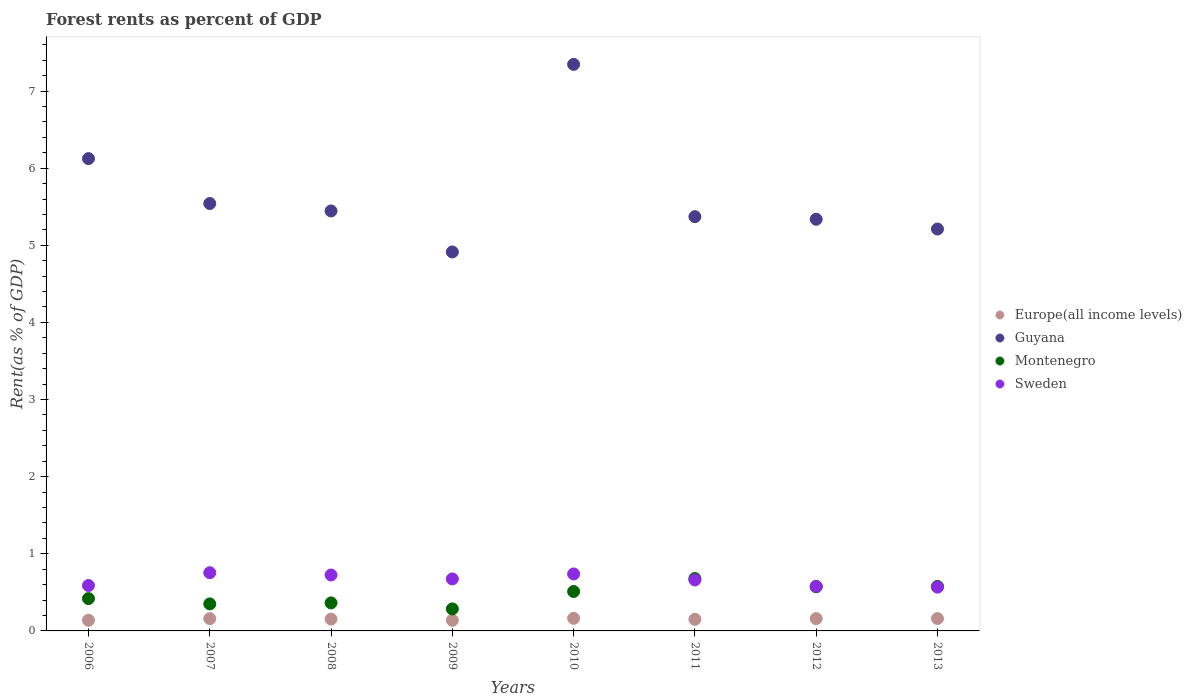What is the forest rent in Montenegro in 2011?
Offer a very short reply. 0.68. Across all years, what is the maximum forest rent in Europe(all income levels)?
Keep it short and to the point. 0.16. Across all years, what is the minimum forest rent in Sweden?
Your response must be concise. 0.57. In which year was the forest rent in Europe(all income levels) minimum?
Your answer should be very brief. 2009. What is the total forest rent in Europe(all income levels) in the graph?
Offer a very short reply. 1.22. What is the difference between the forest rent in Montenegro in 2008 and that in 2011?
Offer a terse response. -0.32. What is the difference between the forest rent in Guyana in 2013 and the forest rent in Montenegro in 2012?
Ensure brevity in your answer.  4.64. What is the average forest rent in Montenegro per year?
Provide a succinct answer. 0.47. In the year 2007, what is the difference between the forest rent in Montenegro and forest rent in Guyana?
Give a very brief answer. -5.19. What is the ratio of the forest rent in Sweden in 2006 to that in 2011?
Provide a short and direct response. 0.89. Is the forest rent in Guyana in 2007 less than that in 2009?
Give a very brief answer. No. What is the difference between the highest and the second highest forest rent in Europe(all income levels)?
Make the answer very short. 0. What is the difference between the highest and the lowest forest rent in Montenegro?
Make the answer very short. 0.39. In how many years, is the forest rent in Europe(all income levels) greater than the average forest rent in Europe(all income levels) taken over all years?
Make the answer very short. 5. Does the forest rent in Guyana monotonically increase over the years?
Your answer should be compact. No. Is the forest rent in Sweden strictly greater than the forest rent in Europe(all income levels) over the years?
Ensure brevity in your answer.  Yes. How many dotlines are there?
Offer a terse response. 4. Are the values on the major ticks of Y-axis written in scientific E-notation?
Your response must be concise. No. Does the graph contain any zero values?
Your answer should be compact. No. Does the graph contain grids?
Ensure brevity in your answer.  No. How many legend labels are there?
Your answer should be compact. 4. What is the title of the graph?
Your answer should be compact. Forest rents as percent of GDP. What is the label or title of the X-axis?
Provide a succinct answer. Years. What is the label or title of the Y-axis?
Keep it short and to the point. Rent(as % of GDP). What is the Rent(as % of GDP) of Europe(all income levels) in 2006?
Your answer should be very brief. 0.14. What is the Rent(as % of GDP) in Guyana in 2006?
Provide a succinct answer. 6.12. What is the Rent(as % of GDP) of Montenegro in 2006?
Your answer should be compact. 0.42. What is the Rent(as % of GDP) of Sweden in 2006?
Your response must be concise. 0.59. What is the Rent(as % of GDP) of Europe(all income levels) in 2007?
Your answer should be very brief. 0.16. What is the Rent(as % of GDP) of Guyana in 2007?
Keep it short and to the point. 5.54. What is the Rent(as % of GDP) in Montenegro in 2007?
Provide a succinct answer. 0.35. What is the Rent(as % of GDP) in Sweden in 2007?
Offer a very short reply. 0.75. What is the Rent(as % of GDP) of Europe(all income levels) in 2008?
Give a very brief answer. 0.15. What is the Rent(as % of GDP) in Guyana in 2008?
Offer a very short reply. 5.45. What is the Rent(as % of GDP) in Montenegro in 2008?
Make the answer very short. 0.36. What is the Rent(as % of GDP) in Sweden in 2008?
Your response must be concise. 0.73. What is the Rent(as % of GDP) of Europe(all income levels) in 2009?
Offer a very short reply. 0.14. What is the Rent(as % of GDP) of Guyana in 2009?
Your answer should be compact. 4.91. What is the Rent(as % of GDP) of Montenegro in 2009?
Offer a very short reply. 0.29. What is the Rent(as % of GDP) in Sweden in 2009?
Offer a terse response. 0.67. What is the Rent(as % of GDP) in Europe(all income levels) in 2010?
Give a very brief answer. 0.16. What is the Rent(as % of GDP) in Guyana in 2010?
Ensure brevity in your answer.  7.35. What is the Rent(as % of GDP) of Montenegro in 2010?
Keep it short and to the point. 0.51. What is the Rent(as % of GDP) in Sweden in 2010?
Keep it short and to the point. 0.74. What is the Rent(as % of GDP) of Europe(all income levels) in 2011?
Ensure brevity in your answer.  0.15. What is the Rent(as % of GDP) in Guyana in 2011?
Provide a short and direct response. 5.37. What is the Rent(as % of GDP) in Montenegro in 2011?
Give a very brief answer. 0.68. What is the Rent(as % of GDP) of Sweden in 2011?
Give a very brief answer. 0.66. What is the Rent(as % of GDP) of Europe(all income levels) in 2012?
Offer a terse response. 0.16. What is the Rent(as % of GDP) of Guyana in 2012?
Offer a very short reply. 5.34. What is the Rent(as % of GDP) of Montenegro in 2012?
Offer a terse response. 0.57. What is the Rent(as % of GDP) of Sweden in 2012?
Provide a succinct answer. 0.58. What is the Rent(as % of GDP) in Europe(all income levels) in 2013?
Ensure brevity in your answer.  0.16. What is the Rent(as % of GDP) of Guyana in 2013?
Provide a succinct answer. 5.21. What is the Rent(as % of GDP) in Montenegro in 2013?
Provide a succinct answer. 0.58. What is the Rent(as % of GDP) in Sweden in 2013?
Offer a very short reply. 0.57. Across all years, what is the maximum Rent(as % of GDP) in Europe(all income levels)?
Your answer should be compact. 0.16. Across all years, what is the maximum Rent(as % of GDP) of Guyana?
Provide a short and direct response. 7.35. Across all years, what is the maximum Rent(as % of GDP) of Montenegro?
Keep it short and to the point. 0.68. Across all years, what is the maximum Rent(as % of GDP) in Sweden?
Your answer should be very brief. 0.75. Across all years, what is the minimum Rent(as % of GDP) of Europe(all income levels)?
Give a very brief answer. 0.14. Across all years, what is the minimum Rent(as % of GDP) in Guyana?
Offer a very short reply. 4.91. Across all years, what is the minimum Rent(as % of GDP) in Montenegro?
Ensure brevity in your answer.  0.29. Across all years, what is the minimum Rent(as % of GDP) of Sweden?
Your response must be concise. 0.57. What is the total Rent(as % of GDP) in Europe(all income levels) in the graph?
Provide a succinct answer. 1.22. What is the total Rent(as % of GDP) in Guyana in the graph?
Make the answer very short. 45.29. What is the total Rent(as % of GDP) in Montenegro in the graph?
Keep it short and to the point. 3.76. What is the total Rent(as % of GDP) of Sweden in the graph?
Your answer should be very brief. 5.29. What is the difference between the Rent(as % of GDP) of Europe(all income levels) in 2006 and that in 2007?
Your answer should be compact. -0.02. What is the difference between the Rent(as % of GDP) in Guyana in 2006 and that in 2007?
Offer a terse response. 0.58. What is the difference between the Rent(as % of GDP) in Montenegro in 2006 and that in 2007?
Provide a succinct answer. 0.07. What is the difference between the Rent(as % of GDP) of Sweden in 2006 and that in 2007?
Your answer should be very brief. -0.17. What is the difference between the Rent(as % of GDP) of Europe(all income levels) in 2006 and that in 2008?
Provide a short and direct response. -0.02. What is the difference between the Rent(as % of GDP) in Guyana in 2006 and that in 2008?
Keep it short and to the point. 0.68. What is the difference between the Rent(as % of GDP) of Montenegro in 2006 and that in 2008?
Your answer should be compact. 0.06. What is the difference between the Rent(as % of GDP) of Sweden in 2006 and that in 2008?
Make the answer very short. -0.14. What is the difference between the Rent(as % of GDP) of Europe(all income levels) in 2006 and that in 2009?
Ensure brevity in your answer.  0. What is the difference between the Rent(as % of GDP) in Guyana in 2006 and that in 2009?
Provide a short and direct response. 1.21. What is the difference between the Rent(as % of GDP) in Montenegro in 2006 and that in 2009?
Provide a succinct answer. 0.13. What is the difference between the Rent(as % of GDP) of Sweden in 2006 and that in 2009?
Provide a succinct answer. -0.09. What is the difference between the Rent(as % of GDP) in Europe(all income levels) in 2006 and that in 2010?
Your answer should be very brief. -0.03. What is the difference between the Rent(as % of GDP) of Guyana in 2006 and that in 2010?
Your answer should be compact. -1.22. What is the difference between the Rent(as % of GDP) of Montenegro in 2006 and that in 2010?
Make the answer very short. -0.09. What is the difference between the Rent(as % of GDP) of Sweden in 2006 and that in 2010?
Your answer should be compact. -0.15. What is the difference between the Rent(as % of GDP) of Europe(all income levels) in 2006 and that in 2011?
Keep it short and to the point. -0.01. What is the difference between the Rent(as % of GDP) of Guyana in 2006 and that in 2011?
Your response must be concise. 0.75. What is the difference between the Rent(as % of GDP) in Montenegro in 2006 and that in 2011?
Give a very brief answer. -0.26. What is the difference between the Rent(as % of GDP) in Sweden in 2006 and that in 2011?
Give a very brief answer. -0.07. What is the difference between the Rent(as % of GDP) in Europe(all income levels) in 2006 and that in 2012?
Your response must be concise. -0.02. What is the difference between the Rent(as % of GDP) in Guyana in 2006 and that in 2012?
Your answer should be compact. 0.79. What is the difference between the Rent(as % of GDP) in Montenegro in 2006 and that in 2012?
Keep it short and to the point. -0.15. What is the difference between the Rent(as % of GDP) of Sweden in 2006 and that in 2012?
Ensure brevity in your answer.  0.01. What is the difference between the Rent(as % of GDP) of Europe(all income levels) in 2006 and that in 2013?
Provide a short and direct response. -0.02. What is the difference between the Rent(as % of GDP) of Montenegro in 2006 and that in 2013?
Provide a succinct answer. -0.16. What is the difference between the Rent(as % of GDP) of Sweden in 2006 and that in 2013?
Provide a short and direct response. 0.02. What is the difference between the Rent(as % of GDP) in Europe(all income levels) in 2007 and that in 2008?
Your answer should be compact. 0.01. What is the difference between the Rent(as % of GDP) in Guyana in 2007 and that in 2008?
Your answer should be very brief. 0.1. What is the difference between the Rent(as % of GDP) in Montenegro in 2007 and that in 2008?
Offer a terse response. -0.01. What is the difference between the Rent(as % of GDP) in Sweden in 2007 and that in 2008?
Your answer should be compact. 0.03. What is the difference between the Rent(as % of GDP) of Europe(all income levels) in 2007 and that in 2009?
Your answer should be compact. 0.02. What is the difference between the Rent(as % of GDP) in Guyana in 2007 and that in 2009?
Give a very brief answer. 0.63. What is the difference between the Rent(as % of GDP) in Montenegro in 2007 and that in 2009?
Provide a succinct answer. 0.06. What is the difference between the Rent(as % of GDP) in Sweden in 2007 and that in 2009?
Provide a short and direct response. 0.08. What is the difference between the Rent(as % of GDP) of Europe(all income levels) in 2007 and that in 2010?
Make the answer very short. -0. What is the difference between the Rent(as % of GDP) of Guyana in 2007 and that in 2010?
Your response must be concise. -1.8. What is the difference between the Rent(as % of GDP) of Montenegro in 2007 and that in 2010?
Give a very brief answer. -0.16. What is the difference between the Rent(as % of GDP) in Sweden in 2007 and that in 2010?
Your response must be concise. 0.02. What is the difference between the Rent(as % of GDP) in Europe(all income levels) in 2007 and that in 2011?
Make the answer very short. 0.01. What is the difference between the Rent(as % of GDP) in Guyana in 2007 and that in 2011?
Keep it short and to the point. 0.17. What is the difference between the Rent(as % of GDP) of Montenegro in 2007 and that in 2011?
Your answer should be very brief. -0.33. What is the difference between the Rent(as % of GDP) in Sweden in 2007 and that in 2011?
Give a very brief answer. 0.09. What is the difference between the Rent(as % of GDP) of Europe(all income levels) in 2007 and that in 2012?
Your answer should be compact. -0. What is the difference between the Rent(as % of GDP) of Guyana in 2007 and that in 2012?
Provide a succinct answer. 0.2. What is the difference between the Rent(as % of GDP) in Montenegro in 2007 and that in 2012?
Provide a short and direct response. -0.22. What is the difference between the Rent(as % of GDP) of Sweden in 2007 and that in 2012?
Provide a succinct answer. 0.18. What is the difference between the Rent(as % of GDP) in Europe(all income levels) in 2007 and that in 2013?
Offer a terse response. -0. What is the difference between the Rent(as % of GDP) of Guyana in 2007 and that in 2013?
Your answer should be compact. 0.33. What is the difference between the Rent(as % of GDP) of Montenegro in 2007 and that in 2013?
Give a very brief answer. -0.23. What is the difference between the Rent(as % of GDP) in Sweden in 2007 and that in 2013?
Give a very brief answer. 0.19. What is the difference between the Rent(as % of GDP) in Europe(all income levels) in 2008 and that in 2009?
Ensure brevity in your answer.  0.02. What is the difference between the Rent(as % of GDP) in Guyana in 2008 and that in 2009?
Offer a very short reply. 0.53. What is the difference between the Rent(as % of GDP) of Montenegro in 2008 and that in 2009?
Ensure brevity in your answer.  0.08. What is the difference between the Rent(as % of GDP) of Sweden in 2008 and that in 2009?
Offer a terse response. 0.05. What is the difference between the Rent(as % of GDP) of Europe(all income levels) in 2008 and that in 2010?
Your answer should be very brief. -0.01. What is the difference between the Rent(as % of GDP) in Guyana in 2008 and that in 2010?
Make the answer very short. -1.9. What is the difference between the Rent(as % of GDP) in Montenegro in 2008 and that in 2010?
Provide a succinct answer. -0.15. What is the difference between the Rent(as % of GDP) of Sweden in 2008 and that in 2010?
Provide a short and direct response. -0.01. What is the difference between the Rent(as % of GDP) of Europe(all income levels) in 2008 and that in 2011?
Offer a terse response. 0. What is the difference between the Rent(as % of GDP) of Guyana in 2008 and that in 2011?
Provide a succinct answer. 0.07. What is the difference between the Rent(as % of GDP) in Montenegro in 2008 and that in 2011?
Your answer should be compact. -0.32. What is the difference between the Rent(as % of GDP) in Sweden in 2008 and that in 2011?
Give a very brief answer. 0.06. What is the difference between the Rent(as % of GDP) in Europe(all income levels) in 2008 and that in 2012?
Provide a short and direct response. -0.01. What is the difference between the Rent(as % of GDP) in Guyana in 2008 and that in 2012?
Give a very brief answer. 0.11. What is the difference between the Rent(as % of GDP) in Montenegro in 2008 and that in 2012?
Ensure brevity in your answer.  -0.21. What is the difference between the Rent(as % of GDP) of Sweden in 2008 and that in 2012?
Offer a terse response. 0.15. What is the difference between the Rent(as % of GDP) of Europe(all income levels) in 2008 and that in 2013?
Provide a succinct answer. -0.01. What is the difference between the Rent(as % of GDP) of Guyana in 2008 and that in 2013?
Make the answer very short. 0.23. What is the difference between the Rent(as % of GDP) in Montenegro in 2008 and that in 2013?
Offer a terse response. -0.21. What is the difference between the Rent(as % of GDP) in Sweden in 2008 and that in 2013?
Your answer should be very brief. 0.16. What is the difference between the Rent(as % of GDP) of Europe(all income levels) in 2009 and that in 2010?
Offer a very short reply. -0.03. What is the difference between the Rent(as % of GDP) in Guyana in 2009 and that in 2010?
Make the answer very short. -2.43. What is the difference between the Rent(as % of GDP) in Montenegro in 2009 and that in 2010?
Your answer should be very brief. -0.23. What is the difference between the Rent(as % of GDP) of Sweden in 2009 and that in 2010?
Your answer should be very brief. -0.06. What is the difference between the Rent(as % of GDP) in Europe(all income levels) in 2009 and that in 2011?
Keep it short and to the point. -0.01. What is the difference between the Rent(as % of GDP) in Guyana in 2009 and that in 2011?
Your response must be concise. -0.46. What is the difference between the Rent(as % of GDP) in Montenegro in 2009 and that in 2011?
Provide a succinct answer. -0.39. What is the difference between the Rent(as % of GDP) of Sweden in 2009 and that in 2011?
Your answer should be compact. 0.01. What is the difference between the Rent(as % of GDP) of Europe(all income levels) in 2009 and that in 2012?
Your response must be concise. -0.02. What is the difference between the Rent(as % of GDP) in Guyana in 2009 and that in 2012?
Offer a terse response. -0.42. What is the difference between the Rent(as % of GDP) in Montenegro in 2009 and that in 2012?
Your answer should be compact. -0.29. What is the difference between the Rent(as % of GDP) of Sweden in 2009 and that in 2012?
Your answer should be compact. 0.1. What is the difference between the Rent(as % of GDP) in Europe(all income levels) in 2009 and that in 2013?
Ensure brevity in your answer.  -0.02. What is the difference between the Rent(as % of GDP) of Guyana in 2009 and that in 2013?
Make the answer very short. -0.3. What is the difference between the Rent(as % of GDP) in Montenegro in 2009 and that in 2013?
Offer a very short reply. -0.29. What is the difference between the Rent(as % of GDP) of Sweden in 2009 and that in 2013?
Your response must be concise. 0.11. What is the difference between the Rent(as % of GDP) of Europe(all income levels) in 2010 and that in 2011?
Give a very brief answer. 0.01. What is the difference between the Rent(as % of GDP) in Guyana in 2010 and that in 2011?
Offer a very short reply. 1.97. What is the difference between the Rent(as % of GDP) in Montenegro in 2010 and that in 2011?
Make the answer very short. -0.17. What is the difference between the Rent(as % of GDP) of Sweden in 2010 and that in 2011?
Your answer should be very brief. 0.08. What is the difference between the Rent(as % of GDP) of Europe(all income levels) in 2010 and that in 2012?
Provide a short and direct response. 0. What is the difference between the Rent(as % of GDP) in Guyana in 2010 and that in 2012?
Your response must be concise. 2.01. What is the difference between the Rent(as % of GDP) in Montenegro in 2010 and that in 2012?
Offer a very short reply. -0.06. What is the difference between the Rent(as % of GDP) in Sweden in 2010 and that in 2012?
Make the answer very short. 0.16. What is the difference between the Rent(as % of GDP) in Europe(all income levels) in 2010 and that in 2013?
Provide a short and direct response. 0. What is the difference between the Rent(as % of GDP) of Guyana in 2010 and that in 2013?
Your answer should be very brief. 2.13. What is the difference between the Rent(as % of GDP) of Montenegro in 2010 and that in 2013?
Give a very brief answer. -0.07. What is the difference between the Rent(as % of GDP) of Sweden in 2010 and that in 2013?
Ensure brevity in your answer.  0.17. What is the difference between the Rent(as % of GDP) of Europe(all income levels) in 2011 and that in 2012?
Ensure brevity in your answer.  -0.01. What is the difference between the Rent(as % of GDP) of Guyana in 2011 and that in 2012?
Give a very brief answer. 0.03. What is the difference between the Rent(as % of GDP) in Montenegro in 2011 and that in 2012?
Make the answer very short. 0.11. What is the difference between the Rent(as % of GDP) in Sweden in 2011 and that in 2012?
Offer a very short reply. 0.08. What is the difference between the Rent(as % of GDP) in Europe(all income levels) in 2011 and that in 2013?
Ensure brevity in your answer.  -0.01. What is the difference between the Rent(as % of GDP) in Guyana in 2011 and that in 2013?
Your response must be concise. 0.16. What is the difference between the Rent(as % of GDP) of Montenegro in 2011 and that in 2013?
Provide a short and direct response. 0.1. What is the difference between the Rent(as % of GDP) in Sweden in 2011 and that in 2013?
Ensure brevity in your answer.  0.09. What is the difference between the Rent(as % of GDP) in Europe(all income levels) in 2012 and that in 2013?
Your response must be concise. -0. What is the difference between the Rent(as % of GDP) of Guyana in 2012 and that in 2013?
Offer a very short reply. 0.13. What is the difference between the Rent(as % of GDP) in Montenegro in 2012 and that in 2013?
Make the answer very short. -0.01. What is the difference between the Rent(as % of GDP) of Sweden in 2012 and that in 2013?
Give a very brief answer. 0.01. What is the difference between the Rent(as % of GDP) in Europe(all income levels) in 2006 and the Rent(as % of GDP) in Guyana in 2007?
Your answer should be very brief. -5.4. What is the difference between the Rent(as % of GDP) of Europe(all income levels) in 2006 and the Rent(as % of GDP) of Montenegro in 2007?
Make the answer very short. -0.21. What is the difference between the Rent(as % of GDP) in Europe(all income levels) in 2006 and the Rent(as % of GDP) in Sweden in 2007?
Ensure brevity in your answer.  -0.62. What is the difference between the Rent(as % of GDP) of Guyana in 2006 and the Rent(as % of GDP) of Montenegro in 2007?
Give a very brief answer. 5.77. What is the difference between the Rent(as % of GDP) in Guyana in 2006 and the Rent(as % of GDP) in Sweden in 2007?
Your response must be concise. 5.37. What is the difference between the Rent(as % of GDP) of Montenegro in 2006 and the Rent(as % of GDP) of Sweden in 2007?
Your answer should be compact. -0.34. What is the difference between the Rent(as % of GDP) in Europe(all income levels) in 2006 and the Rent(as % of GDP) in Guyana in 2008?
Make the answer very short. -5.31. What is the difference between the Rent(as % of GDP) of Europe(all income levels) in 2006 and the Rent(as % of GDP) of Montenegro in 2008?
Your answer should be compact. -0.23. What is the difference between the Rent(as % of GDP) of Europe(all income levels) in 2006 and the Rent(as % of GDP) of Sweden in 2008?
Offer a terse response. -0.59. What is the difference between the Rent(as % of GDP) in Guyana in 2006 and the Rent(as % of GDP) in Montenegro in 2008?
Give a very brief answer. 5.76. What is the difference between the Rent(as % of GDP) in Guyana in 2006 and the Rent(as % of GDP) in Sweden in 2008?
Make the answer very short. 5.4. What is the difference between the Rent(as % of GDP) of Montenegro in 2006 and the Rent(as % of GDP) of Sweden in 2008?
Offer a terse response. -0.31. What is the difference between the Rent(as % of GDP) of Europe(all income levels) in 2006 and the Rent(as % of GDP) of Guyana in 2009?
Offer a terse response. -4.78. What is the difference between the Rent(as % of GDP) in Europe(all income levels) in 2006 and the Rent(as % of GDP) in Montenegro in 2009?
Provide a short and direct response. -0.15. What is the difference between the Rent(as % of GDP) of Europe(all income levels) in 2006 and the Rent(as % of GDP) of Sweden in 2009?
Offer a terse response. -0.54. What is the difference between the Rent(as % of GDP) of Guyana in 2006 and the Rent(as % of GDP) of Montenegro in 2009?
Provide a short and direct response. 5.84. What is the difference between the Rent(as % of GDP) in Guyana in 2006 and the Rent(as % of GDP) in Sweden in 2009?
Offer a terse response. 5.45. What is the difference between the Rent(as % of GDP) in Montenegro in 2006 and the Rent(as % of GDP) in Sweden in 2009?
Offer a terse response. -0.26. What is the difference between the Rent(as % of GDP) of Europe(all income levels) in 2006 and the Rent(as % of GDP) of Guyana in 2010?
Provide a short and direct response. -7.21. What is the difference between the Rent(as % of GDP) of Europe(all income levels) in 2006 and the Rent(as % of GDP) of Montenegro in 2010?
Offer a terse response. -0.37. What is the difference between the Rent(as % of GDP) of Europe(all income levels) in 2006 and the Rent(as % of GDP) of Sweden in 2010?
Ensure brevity in your answer.  -0.6. What is the difference between the Rent(as % of GDP) of Guyana in 2006 and the Rent(as % of GDP) of Montenegro in 2010?
Give a very brief answer. 5.61. What is the difference between the Rent(as % of GDP) of Guyana in 2006 and the Rent(as % of GDP) of Sweden in 2010?
Provide a succinct answer. 5.38. What is the difference between the Rent(as % of GDP) of Montenegro in 2006 and the Rent(as % of GDP) of Sweden in 2010?
Your answer should be compact. -0.32. What is the difference between the Rent(as % of GDP) in Europe(all income levels) in 2006 and the Rent(as % of GDP) in Guyana in 2011?
Offer a very short reply. -5.23. What is the difference between the Rent(as % of GDP) of Europe(all income levels) in 2006 and the Rent(as % of GDP) of Montenegro in 2011?
Offer a very short reply. -0.54. What is the difference between the Rent(as % of GDP) of Europe(all income levels) in 2006 and the Rent(as % of GDP) of Sweden in 2011?
Keep it short and to the point. -0.52. What is the difference between the Rent(as % of GDP) in Guyana in 2006 and the Rent(as % of GDP) in Montenegro in 2011?
Make the answer very short. 5.44. What is the difference between the Rent(as % of GDP) of Guyana in 2006 and the Rent(as % of GDP) of Sweden in 2011?
Offer a very short reply. 5.46. What is the difference between the Rent(as % of GDP) in Montenegro in 2006 and the Rent(as % of GDP) in Sweden in 2011?
Your response must be concise. -0.24. What is the difference between the Rent(as % of GDP) in Europe(all income levels) in 2006 and the Rent(as % of GDP) in Guyana in 2012?
Make the answer very short. -5.2. What is the difference between the Rent(as % of GDP) of Europe(all income levels) in 2006 and the Rent(as % of GDP) of Montenegro in 2012?
Provide a succinct answer. -0.43. What is the difference between the Rent(as % of GDP) in Europe(all income levels) in 2006 and the Rent(as % of GDP) in Sweden in 2012?
Keep it short and to the point. -0.44. What is the difference between the Rent(as % of GDP) of Guyana in 2006 and the Rent(as % of GDP) of Montenegro in 2012?
Give a very brief answer. 5.55. What is the difference between the Rent(as % of GDP) of Guyana in 2006 and the Rent(as % of GDP) of Sweden in 2012?
Your response must be concise. 5.55. What is the difference between the Rent(as % of GDP) in Montenegro in 2006 and the Rent(as % of GDP) in Sweden in 2012?
Ensure brevity in your answer.  -0.16. What is the difference between the Rent(as % of GDP) of Europe(all income levels) in 2006 and the Rent(as % of GDP) of Guyana in 2013?
Offer a terse response. -5.07. What is the difference between the Rent(as % of GDP) of Europe(all income levels) in 2006 and the Rent(as % of GDP) of Montenegro in 2013?
Offer a terse response. -0.44. What is the difference between the Rent(as % of GDP) of Europe(all income levels) in 2006 and the Rent(as % of GDP) of Sweden in 2013?
Offer a very short reply. -0.43. What is the difference between the Rent(as % of GDP) in Guyana in 2006 and the Rent(as % of GDP) in Montenegro in 2013?
Your response must be concise. 5.55. What is the difference between the Rent(as % of GDP) in Guyana in 2006 and the Rent(as % of GDP) in Sweden in 2013?
Keep it short and to the point. 5.56. What is the difference between the Rent(as % of GDP) of Montenegro in 2006 and the Rent(as % of GDP) of Sweden in 2013?
Ensure brevity in your answer.  -0.15. What is the difference between the Rent(as % of GDP) of Europe(all income levels) in 2007 and the Rent(as % of GDP) of Guyana in 2008?
Make the answer very short. -5.29. What is the difference between the Rent(as % of GDP) of Europe(all income levels) in 2007 and the Rent(as % of GDP) of Montenegro in 2008?
Your response must be concise. -0.2. What is the difference between the Rent(as % of GDP) in Europe(all income levels) in 2007 and the Rent(as % of GDP) in Sweden in 2008?
Offer a terse response. -0.57. What is the difference between the Rent(as % of GDP) of Guyana in 2007 and the Rent(as % of GDP) of Montenegro in 2008?
Provide a succinct answer. 5.18. What is the difference between the Rent(as % of GDP) in Guyana in 2007 and the Rent(as % of GDP) in Sweden in 2008?
Give a very brief answer. 4.82. What is the difference between the Rent(as % of GDP) in Montenegro in 2007 and the Rent(as % of GDP) in Sweden in 2008?
Ensure brevity in your answer.  -0.37. What is the difference between the Rent(as % of GDP) in Europe(all income levels) in 2007 and the Rent(as % of GDP) in Guyana in 2009?
Your response must be concise. -4.75. What is the difference between the Rent(as % of GDP) in Europe(all income levels) in 2007 and the Rent(as % of GDP) in Montenegro in 2009?
Ensure brevity in your answer.  -0.13. What is the difference between the Rent(as % of GDP) of Europe(all income levels) in 2007 and the Rent(as % of GDP) of Sweden in 2009?
Ensure brevity in your answer.  -0.52. What is the difference between the Rent(as % of GDP) in Guyana in 2007 and the Rent(as % of GDP) in Montenegro in 2009?
Your answer should be very brief. 5.26. What is the difference between the Rent(as % of GDP) in Guyana in 2007 and the Rent(as % of GDP) in Sweden in 2009?
Offer a very short reply. 4.87. What is the difference between the Rent(as % of GDP) in Montenegro in 2007 and the Rent(as % of GDP) in Sweden in 2009?
Offer a very short reply. -0.32. What is the difference between the Rent(as % of GDP) in Europe(all income levels) in 2007 and the Rent(as % of GDP) in Guyana in 2010?
Your response must be concise. -7.19. What is the difference between the Rent(as % of GDP) of Europe(all income levels) in 2007 and the Rent(as % of GDP) of Montenegro in 2010?
Offer a very short reply. -0.35. What is the difference between the Rent(as % of GDP) of Europe(all income levels) in 2007 and the Rent(as % of GDP) of Sweden in 2010?
Your answer should be compact. -0.58. What is the difference between the Rent(as % of GDP) of Guyana in 2007 and the Rent(as % of GDP) of Montenegro in 2010?
Ensure brevity in your answer.  5.03. What is the difference between the Rent(as % of GDP) in Guyana in 2007 and the Rent(as % of GDP) in Sweden in 2010?
Your answer should be very brief. 4.8. What is the difference between the Rent(as % of GDP) of Montenegro in 2007 and the Rent(as % of GDP) of Sweden in 2010?
Give a very brief answer. -0.39. What is the difference between the Rent(as % of GDP) in Europe(all income levels) in 2007 and the Rent(as % of GDP) in Guyana in 2011?
Provide a succinct answer. -5.21. What is the difference between the Rent(as % of GDP) of Europe(all income levels) in 2007 and the Rent(as % of GDP) of Montenegro in 2011?
Your answer should be compact. -0.52. What is the difference between the Rent(as % of GDP) in Europe(all income levels) in 2007 and the Rent(as % of GDP) in Sweden in 2011?
Make the answer very short. -0.5. What is the difference between the Rent(as % of GDP) of Guyana in 2007 and the Rent(as % of GDP) of Montenegro in 2011?
Give a very brief answer. 4.86. What is the difference between the Rent(as % of GDP) of Guyana in 2007 and the Rent(as % of GDP) of Sweden in 2011?
Your answer should be very brief. 4.88. What is the difference between the Rent(as % of GDP) of Montenegro in 2007 and the Rent(as % of GDP) of Sweden in 2011?
Give a very brief answer. -0.31. What is the difference between the Rent(as % of GDP) of Europe(all income levels) in 2007 and the Rent(as % of GDP) of Guyana in 2012?
Give a very brief answer. -5.18. What is the difference between the Rent(as % of GDP) of Europe(all income levels) in 2007 and the Rent(as % of GDP) of Montenegro in 2012?
Provide a succinct answer. -0.41. What is the difference between the Rent(as % of GDP) in Europe(all income levels) in 2007 and the Rent(as % of GDP) in Sweden in 2012?
Offer a terse response. -0.42. What is the difference between the Rent(as % of GDP) in Guyana in 2007 and the Rent(as % of GDP) in Montenegro in 2012?
Provide a succinct answer. 4.97. What is the difference between the Rent(as % of GDP) in Guyana in 2007 and the Rent(as % of GDP) in Sweden in 2012?
Offer a terse response. 4.96. What is the difference between the Rent(as % of GDP) of Montenegro in 2007 and the Rent(as % of GDP) of Sweden in 2012?
Give a very brief answer. -0.23. What is the difference between the Rent(as % of GDP) of Europe(all income levels) in 2007 and the Rent(as % of GDP) of Guyana in 2013?
Offer a terse response. -5.05. What is the difference between the Rent(as % of GDP) in Europe(all income levels) in 2007 and the Rent(as % of GDP) in Montenegro in 2013?
Give a very brief answer. -0.42. What is the difference between the Rent(as % of GDP) of Europe(all income levels) in 2007 and the Rent(as % of GDP) of Sweden in 2013?
Your response must be concise. -0.41. What is the difference between the Rent(as % of GDP) in Guyana in 2007 and the Rent(as % of GDP) in Montenegro in 2013?
Offer a very short reply. 4.96. What is the difference between the Rent(as % of GDP) of Guyana in 2007 and the Rent(as % of GDP) of Sweden in 2013?
Offer a very short reply. 4.97. What is the difference between the Rent(as % of GDP) of Montenegro in 2007 and the Rent(as % of GDP) of Sweden in 2013?
Give a very brief answer. -0.22. What is the difference between the Rent(as % of GDP) in Europe(all income levels) in 2008 and the Rent(as % of GDP) in Guyana in 2009?
Provide a short and direct response. -4.76. What is the difference between the Rent(as % of GDP) of Europe(all income levels) in 2008 and the Rent(as % of GDP) of Montenegro in 2009?
Your answer should be very brief. -0.13. What is the difference between the Rent(as % of GDP) of Europe(all income levels) in 2008 and the Rent(as % of GDP) of Sweden in 2009?
Offer a terse response. -0.52. What is the difference between the Rent(as % of GDP) of Guyana in 2008 and the Rent(as % of GDP) of Montenegro in 2009?
Your response must be concise. 5.16. What is the difference between the Rent(as % of GDP) in Guyana in 2008 and the Rent(as % of GDP) in Sweden in 2009?
Offer a terse response. 4.77. What is the difference between the Rent(as % of GDP) in Montenegro in 2008 and the Rent(as % of GDP) in Sweden in 2009?
Make the answer very short. -0.31. What is the difference between the Rent(as % of GDP) of Europe(all income levels) in 2008 and the Rent(as % of GDP) of Guyana in 2010?
Offer a very short reply. -7.19. What is the difference between the Rent(as % of GDP) in Europe(all income levels) in 2008 and the Rent(as % of GDP) in Montenegro in 2010?
Your answer should be very brief. -0.36. What is the difference between the Rent(as % of GDP) in Europe(all income levels) in 2008 and the Rent(as % of GDP) in Sweden in 2010?
Offer a terse response. -0.58. What is the difference between the Rent(as % of GDP) of Guyana in 2008 and the Rent(as % of GDP) of Montenegro in 2010?
Offer a terse response. 4.93. What is the difference between the Rent(as % of GDP) of Guyana in 2008 and the Rent(as % of GDP) of Sweden in 2010?
Ensure brevity in your answer.  4.71. What is the difference between the Rent(as % of GDP) of Montenegro in 2008 and the Rent(as % of GDP) of Sweden in 2010?
Your answer should be very brief. -0.38. What is the difference between the Rent(as % of GDP) of Europe(all income levels) in 2008 and the Rent(as % of GDP) of Guyana in 2011?
Make the answer very short. -5.22. What is the difference between the Rent(as % of GDP) in Europe(all income levels) in 2008 and the Rent(as % of GDP) in Montenegro in 2011?
Provide a short and direct response. -0.53. What is the difference between the Rent(as % of GDP) of Europe(all income levels) in 2008 and the Rent(as % of GDP) of Sweden in 2011?
Offer a very short reply. -0.51. What is the difference between the Rent(as % of GDP) of Guyana in 2008 and the Rent(as % of GDP) of Montenegro in 2011?
Offer a terse response. 4.77. What is the difference between the Rent(as % of GDP) of Guyana in 2008 and the Rent(as % of GDP) of Sweden in 2011?
Keep it short and to the point. 4.78. What is the difference between the Rent(as % of GDP) of Montenegro in 2008 and the Rent(as % of GDP) of Sweden in 2011?
Offer a very short reply. -0.3. What is the difference between the Rent(as % of GDP) in Europe(all income levels) in 2008 and the Rent(as % of GDP) in Guyana in 2012?
Keep it short and to the point. -5.18. What is the difference between the Rent(as % of GDP) in Europe(all income levels) in 2008 and the Rent(as % of GDP) in Montenegro in 2012?
Give a very brief answer. -0.42. What is the difference between the Rent(as % of GDP) of Europe(all income levels) in 2008 and the Rent(as % of GDP) of Sweden in 2012?
Your response must be concise. -0.42. What is the difference between the Rent(as % of GDP) of Guyana in 2008 and the Rent(as % of GDP) of Montenegro in 2012?
Give a very brief answer. 4.87. What is the difference between the Rent(as % of GDP) in Guyana in 2008 and the Rent(as % of GDP) in Sweden in 2012?
Your answer should be compact. 4.87. What is the difference between the Rent(as % of GDP) in Montenegro in 2008 and the Rent(as % of GDP) in Sweden in 2012?
Keep it short and to the point. -0.21. What is the difference between the Rent(as % of GDP) of Europe(all income levels) in 2008 and the Rent(as % of GDP) of Guyana in 2013?
Ensure brevity in your answer.  -5.06. What is the difference between the Rent(as % of GDP) of Europe(all income levels) in 2008 and the Rent(as % of GDP) of Montenegro in 2013?
Ensure brevity in your answer.  -0.42. What is the difference between the Rent(as % of GDP) of Europe(all income levels) in 2008 and the Rent(as % of GDP) of Sweden in 2013?
Provide a succinct answer. -0.41. What is the difference between the Rent(as % of GDP) in Guyana in 2008 and the Rent(as % of GDP) in Montenegro in 2013?
Make the answer very short. 4.87. What is the difference between the Rent(as % of GDP) in Guyana in 2008 and the Rent(as % of GDP) in Sweden in 2013?
Keep it short and to the point. 4.88. What is the difference between the Rent(as % of GDP) in Montenegro in 2008 and the Rent(as % of GDP) in Sweden in 2013?
Ensure brevity in your answer.  -0.2. What is the difference between the Rent(as % of GDP) of Europe(all income levels) in 2009 and the Rent(as % of GDP) of Guyana in 2010?
Keep it short and to the point. -7.21. What is the difference between the Rent(as % of GDP) of Europe(all income levels) in 2009 and the Rent(as % of GDP) of Montenegro in 2010?
Make the answer very short. -0.37. What is the difference between the Rent(as % of GDP) of Europe(all income levels) in 2009 and the Rent(as % of GDP) of Sweden in 2010?
Provide a short and direct response. -0.6. What is the difference between the Rent(as % of GDP) in Guyana in 2009 and the Rent(as % of GDP) in Montenegro in 2010?
Your response must be concise. 4.4. What is the difference between the Rent(as % of GDP) in Guyana in 2009 and the Rent(as % of GDP) in Sweden in 2010?
Offer a terse response. 4.17. What is the difference between the Rent(as % of GDP) of Montenegro in 2009 and the Rent(as % of GDP) of Sweden in 2010?
Provide a short and direct response. -0.45. What is the difference between the Rent(as % of GDP) in Europe(all income levels) in 2009 and the Rent(as % of GDP) in Guyana in 2011?
Offer a very short reply. -5.23. What is the difference between the Rent(as % of GDP) of Europe(all income levels) in 2009 and the Rent(as % of GDP) of Montenegro in 2011?
Offer a very short reply. -0.54. What is the difference between the Rent(as % of GDP) in Europe(all income levels) in 2009 and the Rent(as % of GDP) in Sweden in 2011?
Give a very brief answer. -0.52. What is the difference between the Rent(as % of GDP) of Guyana in 2009 and the Rent(as % of GDP) of Montenegro in 2011?
Your response must be concise. 4.23. What is the difference between the Rent(as % of GDP) of Guyana in 2009 and the Rent(as % of GDP) of Sweden in 2011?
Your response must be concise. 4.25. What is the difference between the Rent(as % of GDP) of Montenegro in 2009 and the Rent(as % of GDP) of Sweden in 2011?
Ensure brevity in your answer.  -0.38. What is the difference between the Rent(as % of GDP) of Europe(all income levels) in 2009 and the Rent(as % of GDP) of Guyana in 2012?
Your answer should be compact. -5.2. What is the difference between the Rent(as % of GDP) of Europe(all income levels) in 2009 and the Rent(as % of GDP) of Montenegro in 2012?
Your answer should be compact. -0.43. What is the difference between the Rent(as % of GDP) in Europe(all income levels) in 2009 and the Rent(as % of GDP) in Sweden in 2012?
Give a very brief answer. -0.44. What is the difference between the Rent(as % of GDP) of Guyana in 2009 and the Rent(as % of GDP) of Montenegro in 2012?
Your response must be concise. 4.34. What is the difference between the Rent(as % of GDP) in Guyana in 2009 and the Rent(as % of GDP) in Sweden in 2012?
Give a very brief answer. 4.34. What is the difference between the Rent(as % of GDP) of Montenegro in 2009 and the Rent(as % of GDP) of Sweden in 2012?
Keep it short and to the point. -0.29. What is the difference between the Rent(as % of GDP) of Europe(all income levels) in 2009 and the Rent(as % of GDP) of Guyana in 2013?
Give a very brief answer. -5.07. What is the difference between the Rent(as % of GDP) in Europe(all income levels) in 2009 and the Rent(as % of GDP) in Montenegro in 2013?
Offer a terse response. -0.44. What is the difference between the Rent(as % of GDP) in Europe(all income levels) in 2009 and the Rent(as % of GDP) in Sweden in 2013?
Provide a short and direct response. -0.43. What is the difference between the Rent(as % of GDP) of Guyana in 2009 and the Rent(as % of GDP) of Montenegro in 2013?
Offer a very short reply. 4.34. What is the difference between the Rent(as % of GDP) in Guyana in 2009 and the Rent(as % of GDP) in Sweden in 2013?
Give a very brief answer. 4.35. What is the difference between the Rent(as % of GDP) in Montenegro in 2009 and the Rent(as % of GDP) in Sweden in 2013?
Your response must be concise. -0.28. What is the difference between the Rent(as % of GDP) in Europe(all income levels) in 2010 and the Rent(as % of GDP) in Guyana in 2011?
Ensure brevity in your answer.  -5.21. What is the difference between the Rent(as % of GDP) of Europe(all income levels) in 2010 and the Rent(as % of GDP) of Montenegro in 2011?
Ensure brevity in your answer.  -0.52. What is the difference between the Rent(as % of GDP) in Europe(all income levels) in 2010 and the Rent(as % of GDP) in Sweden in 2011?
Provide a short and direct response. -0.5. What is the difference between the Rent(as % of GDP) in Guyana in 2010 and the Rent(as % of GDP) in Montenegro in 2011?
Keep it short and to the point. 6.67. What is the difference between the Rent(as % of GDP) of Guyana in 2010 and the Rent(as % of GDP) of Sweden in 2011?
Give a very brief answer. 6.68. What is the difference between the Rent(as % of GDP) of Montenegro in 2010 and the Rent(as % of GDP) of Sweden in 2011?
Make the answer very short. -0.15. What is the difference between the Rent(as % of GDP) of Europe(all income levels) in 2010 and the Rent(as % of GDP) of Guyana in 2012?
Provide a short and direct response. -5.17. What is the difference between the Rent(as % of GDP) of Europe(all income levels) in 2010 and the Rent(as % of GDP) of Montenegro in 2012?
Make the answer very short. -0.41. What is the difference between the Rent(as % of GDP) in Europe(all income levels) in 2010 and the Rent(as % of GDP) in Sweden in 2012?
Your response must be concise. -0.41. What is the difference between the Rent(as % of GDP) of Guyana in 2010 and the Rent(as % of GDP) of Montenegro in 2012?
Your answer should be compact. 6.77. What is the difference between the Rent(as % of GDP) in Guyana in 2010 and the Rent(as % of GDP) in Sweden in 2012?
Make the answer very short. 6.77. What is the difference between the Rent(as % of GDP) in Montenegro in 2010 and the Rent(as % of GDP) in Sweden in 2012?
Offer a very short reply. -0.07. What is the difference between the Rent(as % of GDP) of Europe(all income levels) in 2010 and the Rent(as % of GDP) of Guyana in 2013?
Ensure brevity in your answer.  -5.05. What is the difference between the Rent(as % of GDP) in Europe(all income levels) in 2010 and the Rent(as % of GDP) in Montenegro in 2013?
Ensure brevity in your answer.  -0.41. What is the difference between the Rent(as % of GDP) in Europe(all income levels) in 2010 and the Rent(as % of GDP) in Sweden in 2013?
Your answer should be compact. -0.4. What is the difference between the Rent(as % of GDP) of Guyana in 2010 and the Rent(as % of GDP) of Montenegro in 2013?
Make the answer very short. 6.77. What is the difference between the Rent(as % of GDP) in Guyana in 2010 and the Rent(as % of GDP) in Sweden in 2013?
Your answer should be very brief. 6.78. What is the difference between the Rent(as % of GDP) in Montenegro in 2010 and the Rent(as % of GDP) in Sweden in 2013?
Your answer should be compact. -0.06. What is the difference between the Rent(as % of GDP) of Europe(all income levels) in 2011 and the Rent(as % of GDP) of Guyana in 2012?
Keep it short and to the point. -5.19. What is the difference between the Rent(as % of GDP) of Europe(all income levels) in 2011 and the Rent(as % of GDP) of Montenegro in 2012?
Ensure brevity in your answer.  -0.42. What is the difference between the Rent(as % of GDP) in Europe(all income levels) in 2011 and the Rent(as % of GDP) in Sweden in 2012?
Ensure brevity in your answer.  -0.43. What is the difference between the Rent(as % of GDP) in Guyana in 2011 and the Rent(as % of GDP) in Montenegro in 2012?
Your answer should be compact. 4.8. What is the difference between the Rent(as % of GDP) in Guyana in 2011 and the Rent(as % of GDP) in Sweden in 2012?
Provide a short and direct response. 4.79. What is the difference between the Rent(as % of GDP) of Montenegro in 2011 and the Rent(as % of GDP) of Sweden in 2012?
Give a very brief answer. 0.1. What is the difference between the Rent(as % of GDP) of Europe(all income levels) in 2011 and the Rent(as % of GDP) of Guyana in 2013?
Offer a very short reply. -5.06. What is the difference between the Rent(as % of GDP) of Europe(all income levels) in 2011 and the Rent(as % of GDP) of Montenegro in 2013?
Ensure brevity in your answer.  -0.43. What is the difference between the Rent(as % of GDP) of Europe(all income levels) in 2011 and the Rent(as % of GDP) of Sweden in 2013?
Ensure brevity in your answer.  -0.42. What is the difference between the Rent(as % of GDP) of Guyana in 2011 and the Rent(as % of GDP) of Montenegro in 2013?
Make the answer very short. 4.79. What is the difference between the Rent(as % of GDP) in Guyana in 2011 and the Rent(as % of GDP) in Sweden in 2013?
Offer a terse response. 4.8. What is the difference between the Rent(as % of GDP) in Montenegro in 2011 and the Rent(as % of GDP) in Sweden in 2013?
Your answer should be very brief. 0.11. What is the difference between the Rent(as % of GDP) in Europe(all income levels) in 2012 and the Rent(as % of GDP) in Guyana in 2013?
Your answer should be very brief. -5.05. What is the difference between the Rent(as % of GDP) in Europe(all income levels) in 2012 and the Rent(as % of GDP) in Montenegro in 2013?
Provide a succinct answer. -0.42. What is the difference between the Rent(as % of GDP) of Europe(all income levels) in 2012 and the Rent(as % of GDP) of Sweden in 2013?
Provide a short and direct response. -0.41. What is the difference between the Rent(as % of GDP) of Guyana in 2012 and the Rent(as % of GDP) of Montenegro in 2013?
Keep it short and to the point. 4.76. What is the difference between the Rent(as % of GDP) of Guyana in 2012 and the Rent(as % of GDP) of Sweden in 2013?
Keep it short and to the point. 4.77. What is the difference between the Rent(as % of GDP) of Montenegro in 2012 and the Rent(as % of GDP) of Sweden in 2013?
Give a very brief answer. 0. What is the average Rent(as % of GDP) in Europe(all income levels) per year?
Keep it short and to the point. 0.15. What is the average Rent(as % of GDP) of Guyana per year?
Provide a short and direct response. 5.66. What is the average Rent(as % of GDP) of Montenegro per year?
Provide a succinct answer. 0.47. What is the average Rent(as % of GDP) in Sweden per year?
Make the answer very short. 0.66. In the year 2006, what is the difference between the Rent(as % of GDP) of Europe(all income levels) and Rent(as % of GDP) of Guyana?
Ensure brevity in your answer.  -5.99. In the year 2006, what is the difference between the Rent(as % of GDP) in Europe(all income levels) and Rent(as % of GDP) in Montenegro?
Ensure brevity in your answer.  -0.28. In the year 2006, what is the difference between the Rent(as % of GDP) in Europe(all income levels) and Rent(as % of GDP) in Sweden?
Offer a very short reply. -0.45. In the year 2006, what is the difference between the Rent(as % of GDP) in Guyana and Rent(as % of GDP) in Montenegro?
Offer a terse response. 5.7. In the year 2006, what is the difference between the Rent(as % of GDP) of Guyana and Rent(as % of GDP) of Sweden?
Make the answer very short. 5.53. In the year 2006, what is the difference between the Rent(as % of GDP) in Montenegro and Rent(as % of GDP) in Sweden?
Provide a short and direct response. -0.17. In the year 2007, what is the difference between the Rent(as % of GDP) of Europe(all income levels) and Rent(as % of GDP) of Guyana?
Make the answer very short. -5.38. In the year 2007, what is the difference between the Rent(as % of GDP) of Europe(all income levels) and Rent(as % of GDP) of Montenegro?
Ensure brevity in your answer.  -0.19. In the year 2007, what is the difference between the Rent(as % of GDP) of Europe(all income levels) and Rent(as % of GDP) of Sweden?
Offer a terse response. -0.6. In the year 2007, what is the difference between the Rent(as % of GDP) in Guyana and Rent(as % of GDP) in Montenegro?
Keep it short and to the point. 5.19. In the year 2007, what is the difference between the Rent(as % of GDP) in Guyana and Rent(as % of GDP) in Sweden?
Offer a very short reply. 4.79. In the year 2007, what is the difference between the Rent(as % of GDP) of Montenegro and Rent(as % of GDP) of Sweden?
Your answer should be very brief. -0.4. In the year 2008, what is the difference between the Rent(as % of GDP) of Europe(all income levels) and Rent(as % of GDP) of Guyana?
Provide a short and direct response. -5.29. In the year 2008, what is the difference between the Rent(as % of GDP) of Europe(all income levels) and Rent(as % of GDP) of Montenegro?
Make the answer very short. -0.21. In the year 2008, what is the difference between the Rent(as % of GDP) of Europe(all income levels) and Rent(as % of GDP) of Sweden?
Give a very brief answer. -0.57. In the year 2008, what is the difference between the Rent(as % of GDP) in Guyana and Rent(as % of GDP) in Montenegro?
Ensure brevity in your answer.  5.08. In the year 2008, what is the difference between the Rent(as % of GDP) in Guyana and Rent(as % of GDP) in Sweden?
Your answer should be compact. 4.72. In the year 2008, what is the difference between the Rent(as % of GDP) in Montenegro and Rent(as % of GDP) in Sweden?
Provide a short and direct response. -0.36. In the year 2009, what is the difference between the Rent(as % of GDP) of Europe(all income levels) and Rent(as % of GDP) of Guyana?
Make the answer very short. -4.78. In the year 2009, what is the difference between the Rent(as % of GDP) of Europe(all income levels) and Rent(as % of GDP) of Montenegro?
Your answer should be very brief. -0.15. In the year 2009, what is the difference between the Rent(as % of GDP) in Europe(all income levels) and Rent(as % of GDP) in Sweden?
Offer a very short reply. -0.54. In the year 2009, what is the difference between the Rent(as % of GDP) of Guyana and Rent(as % of GDP) of Montenegro?
Give a very brief answer. 4.63. In the year 2009, what is the difference between the Rent(as % of GDP) in Guyana and Rent(as % of GDP) in Sweden?
Offer a very short reply. 4.24. In the year 2009, what is the difference between the Rent(as % of GDP) of Montenegro and Rent(as % of GDP) of Sweden?
Provide a succinct answer. -0.39. In the year 2010, what is the difference between the Rent(as % of GDP) in Europe(all income levels) and Rent(as % of GDP) in Guyana?
Ensure brevity in your answer.  -7.18. In the year 2010, what is the difference between the Rent(as % of GDP) in Europe(all income levels) and Rent(as % of GDP) in Montenegro?
Offer a terse response. -0.35. In the year 2010, what is the difference between the Rent(as % of GDP) of Europe(all income levels) and Rent(as % of GDP) of Sweden?
Your answer should be compact. -0.58. In the year 2010, what is the difference between the Rent(as % of GDP) of Guyana and Rent(as % of GDP) of Montenegro?
Your answer should be very brief. 6.83. In the year 2010, what is the difference between the Rent(as % of GDP) of Guyana and Rent(as % of GDP) of Sweden?
Provide a short and direct response. 6.61. In the year 2010, what is the difference between the Rent(as % of GDP) in Montenegro and Rent(as % of GDP) in Sweden?
Ensure brevity in your answer.  -0.23. In the year 2011, what is the difference between the Rent(as % of GDP) of Europe(all income levels) and Rent(as % of GDP) of Guyana?
Make the answer very short. -5.22. In the year 2011, what is the difference between the Rent(as % of GDP) of Europe(all income levels) and Rent(as % of GDP) of Montenegro?
Your answer should be very brief. -0.53. In the year 2011, what is the difference between the Rent(as % of GDP) in Europe(all income levels) and Rent(as % of GDP) in Sweden?
Provide a succinct answer. -0.51. In the year 2011, what is the difference between the Rent(as % of GDP) in Guyana and Rent(as % of GDP) in Montenegro?
Provide a short and direct response. 4.69. In the year 2011, what is the difference between the Rent(as % of GDP) of Guyana and Rent(as % of GDP) of Sweden?
Make the answer very short. 4.71. In the year 2011, what is the difference between the Rent(as % of GDP) in Montenegro and Rent(as % of GDP) in Sweden?
Your response must be concise. 0.02. In the year 2012, what is the difference between the Rent(as % of GDP) of Europe(all income levels) and Rent(as % of GDP) of Guyana?
Your answer should be compact. -5.18. In the year 2012, what is the difference between the Rent(as % of GDP) in Europe(all income levels) and Rent(as % of GDP) in Montenegro?
Your answer should be very brief. -0.41. In the year 2012, what is the difference between the Rent(as % of GDP) of Europe(all income levels) and Rent(as % of GDP) of Sweden?
Make the answer very short. -0.42. In the year 2012, what is the difference between the Rent(as % of GDP) of Guyana and Rent(as % of GDP) of Montenegro?
Keep it short and to the point. 4.76. In the year 2012, what is the difference between the Rent(as % of GDP) in Guyana and Rent(as % of GDP) in Sweden?
Offer a terse response. 4.76. In the year 2012, what is the difference between the Rent(as % of GDP) of Montenegro and Rent(as % of GDP) of Sweden?
Offer a terse response. -0.01. In the year 2013, what is the difference between the Rent(as % of GDP) of Europe(all income levels) and Rent(as % of GDP) of Guyana?
Offer a very short reply. -5.05. In the year 2013, what is the difference between the Rent(as % of GDP) of Europe(all income levels) and Rent(as % of GDP) of Montenegro?
Keep it short and to the point. -0.42. In the year 2013, what is the difference between the Rent(as % of GDP) in Europe(all income levels) and Rent(as % of GDP) in Sweden?
Make the answer very short. -0.41. In the year 2013, what is the difference between the Rent(as % of GDP) in Guyana and Rent(as % of GDP) in Montenegro?
Keep it short and to the point. 4.63. In the year 2013, what is the difference between the Rent(as % of GDP) of Guyana and Rent(as % of GDP) of Sweden?
Make the answer very short. 4.64. In the year 2013, what is the difference between the Rent(as % of GDP) of Montenegro and Rent(as % of GDP) of Sweden?
Keep it short and to the point. 0.01. What is the ratio of the Rent(as % of GDP) in Europe(all income levels) in 2006 to that in 2007?
Your answer should be compact. 0.87. What is the ratio of the Rent(as % of GDP) in Guyana in 2006 to that in 2007?
Give a very brief answer. 1.1. What is the ratio of the Rent(as % of GDP) of Montenegro in 2006 to that in 2007?
Ensure brevity in your answer.  1.2. What is the ratio of the Rent(as % of GDP) in Sweden in 2006 to that in 2007?
Give a very brief answer. 0.78. What is the ratio of the Rent(as % of GDP) of Europe(all income levels) in 2006 to that in 2008?
Offer a terse response. 0.9. What is the ratio of the Rent(as % of GDP) in Guyana in 2006 to that in 2008?
Your answer should be very brief. 1.12. What is the ratio of the Rent(as % of GDP) in Montenegro in 2006 to that in 2008?
Give a very brief answer. 1.15. What is the ratio of the Rent(as % of GDP) of Sweden in 2006 to that in 2008?
Your response must be concise. 0.81. What is the ratio of the Rent(as % of GDP) in Guyana in 2006 to that in 2009?
Your response must be concise. 1.25. What is the ratio of the Rent(as % of GDP) of Montenegro in 2006 to that in 2009?
Provide a short and direct response. 1.47. What is the ratio of the Rent(as % of GDP) of Sweden in 2006 to that in 2009?
Give a very brief answer. 0.87. What is the ratio of the Rent(as % of GDP) in Europe(all income levels) in 2006 to that in 2010?
Offer a terse response. 0.85. What is the ratio of the Rent(as % of GDP) in Guyana in 2006 to that in 2010?
Ensure brevity in your answer.  0.83. What is the ratio of the Rent(as % of GDP) in Montenegro in 2006 to that in 2010?
Provide a succinct answer. 0.82. What is the ratio of the Rent(as % of GDP) in Sweden in 2006 to that in 2010?
Offer a terse response. 0.8. What is the ratio of the Rent(as % of GDP) of Europe(all income levels) in 2006 to that in 2011?
Offer a very short reply. 0.92. What is the ratio of the Rent(as % of GDP) of Guyana in 2006 to that in 2011?
Your response must be concise. 1.14. What is the ratio of the Rent(as % of GDP) in Montenegro in 2006 to that in 2011?
Offer a terse response. 0.62. What is the ratio of the Rent(as % of GDP) of Sweden in 2006 to that in 2011?
Your answer should be compact. 0.89. What is the ratio of the Rent(as % of GDP) in Europe(all income levels) in 2006 to that in 2012?
Your response must be concise. 0.87. What is the ratio of the Rent(as % of GDP) in Guyana in 2006 to that in 2012?
Make the answer very short. 1.15. What is the ratio of the Rent(as % of GDP) of Montenegro in 2006 to that in 2012?
Your answer should be very brief. 0.73. What is the ratio of the Rent(as % of GDP) in Sweden in 2006 to that in 2012?
Offer a very short reply. 1.02. What is the ratio of the Rent(as % of GDP) in Europe(all income levels) in 2006 to that in 2013?
Your response must be concise. 0.86. What is the ratio of the Rent(as % of GDP) in Guyana in 2006 to that in 2013?
Provide a short and direct response. 1.18. What is the ratio of the Rent(as % of GDP) of Montenegro in 2006 to that in 2013?
Your response must be concise. 0.73. What is the ratio of the Rent(as % of GDP) of Sweden in 2006 to that in 2013?
Keep it short and to the point. 1.04. What is the ratio of the Rent(as % of GDP) of Europe(all income levels) in 2007 to that in 2008?
Provide a succinct answer. 1.04. What is the ratio of the Rent(as % of GDP) of Guyana in 2007 to that in 2008?
Provide a short and direct response. 1.02. What is the ratio of the Rent(as % of GDP) of Montenegro in 2007 to that in 2008?
Give a very brief answer. 0.96. What is the ratio of the Rent(as % of GDP) in Sweden in 2007 to that in 2008?
Your answer should be very brief. 1.04. What is the ratio of the Rent(as % of GDP) in Europe(all income levels) in 2007 to that in 2009?
Offer a very short reply. 1.16. What is the ratio of the Rent(as % of GDP) in Guyana in 2007 to that in 2009?
Provide a succinct answer. 1.13. What is the ratio of the Rent(as % of GDP) in Montenegro in 2007 to that in 2009?
Offer a terse response. 1.23. What is the ratio of the Rent(as % of GDP) of Sweden in 2007 to that in 2009?
Offer a very short reply. 1.12. What is the ratio of the Rent(as % of GDP) of Europe(all income levels) in 2007 to that in 2010?
Ensure brevity in your answer.  0.97. What is the ratio of the Rent(as % of GDP) in Guyana in 2007 to that in 2010?
Your response must be concise. 0.75. What is the ratio of the Rent(as % of GDP) of Montenegro in 2007 to that in 2010?
Ensure brevity in your answer.  0.69. What is the ratio of the Rent(as % of GDP) in Sweden in 2007 to that in 2010?
Your response must be concise. 1.02. What is the ratio of the Rent(as % of GDP) of Europe(all income levels) in 2007 to that in 2011?
Make the answer very short. 1.06. What is the ratio of the Rent(as % of GDP) in Guyana in 2007 to that in 2011?
Offer a terse response. 1.03. What is the ratio of the Rent(as % of GDP) in Montenegro in 2007 to that in 2011?
Ensure brevity in your answer.  0.52. What is the ratio of the Rent(as % of GDP) in Sweden in 2007 to that in 2011?
Your response must be concise. 1.14. What is the ratio of the Rent(as % of GDP) in Guyana in 2007 to that in 2012?
Your answer should be compact. 1.04. What is the ratio of the Rent(as % of GDP) of Montenegro in 2007 to that in 2012?
Give a very brief answer. 0.61. What is the ratio of the Rent(as % of GDP) in Sweden in 2007 to that in 2012?
Give a very brief answer. 1.31. What is the ratio of the Rent(as % of GDP) of Guyana in 2007 to that in 2013?
Provide a succinct answer. 1.06. What is the ratio of the Rent(as % of GDP) in Montenegro in 2007 to that in 2013?
Give a very brief answer. 0.61. What is the ratio of the Rent(as % of GDP) of Sweden in 2007 to that in 2013?
Give a very brief answer. 1.33. What is the ratio of the Rent(as % of GDP) of Europe(all income levels) in 2008 to that in 2009?
Provide a short and direct response. 1.12. What is the ratio of the Rent(as % of GDP) of Guyana in 2008 to that in 2009?
Provide a short and direct response. 1.11. What is the ratio of the Rent(as % of GDP) of Montenegro in 2008 to that in 2009?
Ensure brevity in your answer.  1.27. What is the ratio of the Rent(as % of GDP) of Sweden in 2008 to that in 2009?
Make the answer very short. 1.08. What is the ratio of the Rent(as % of GDP) of Europe(all income levels) in 2008 to that in 2010?
Offer a very short reply. 0.94. What is the ratio of the Rent(as % of GDP) in Guyana in 2008 to that in 2010?
Your response must be concise. 0.74. What is the ratio of the Rent(as % of GDP) in Montenegro in 2008 to that in 2010?
Offer a very short reply. 0.71. What is the ratio of the Rent(as % of GDP) of Sweden in 2008 to that in 2010?
Provide a short and direct response. 0.98. What is the ratio of the Rent(as % of GDP) in Europe(all income levels) in 2008 to that in 2011?
Offer a terse response. 1.02. What is the ratio of the Rent(as % of GDP) in Guyana in 2008 to that in 2011?
Provide a succinct answer. 1.01. What is the ratio of the Rent(as % of GDP) of Montenegro in 2008 to that in 2011?
Offer a terse response. 0.54. What is the ratio of the Rent(as % of GDP) in Sweden in 2008 to that in 2011?
Your response must be concise. 1.1. What is the ratio of the Rent(as % of GDP) of Europe(all income levels) in 2008 to that in 2012?
Your answer should be very brief. 0.96. What is the ratio of the Rent(as % of GDP) in Guyana in 2008 to that in 2012?
Your response must be concise. 1.02. What is the ratio of the Rent(as % of GDP) in Montenegro in 2008 to that in 2012?
Provide a succinct answer. 0.63. What is the ratio of the Rent(as % of GDP) in Sweden in 2008 to that in 2012?
Your answer should be compact. 1.25. What is the ratio of the Rent(as % of GDP) in Europe(all income levels) in 2008 to that in 2013?
Provide a succinct answer. 0.96. What is the ratio of the Rent(as % of GDP) in Guyana in 2008 to that in 2013?
Give a very brief answer. 1.04. What is the ratio of the Rent(as % of GDP) in Montenegro in 2008 to that in 2013?
Provide a short and direct response. 0.63. What is the ratio of the Rent(as % of GDP) in Sweden in 2008 to that in 2013?
Make the answer very short. 1.28. What is the ratio of the Rent(as % of GDP) in Europe(all income levels) in 2009 to that in 2010?
Your answer should be very brief. 0.84. What is the ratio of the Rent(as % of GDP) in Guyana in 2009 to that in 2010?
Ensure brevity in your answer.  0.67. What is the ratio of the Rent(as % of GDP) in Montenegro in 2009 to that in 2010?
Ensure brevity in your answer.  0.56. What is the ratio of the Rent(as % of GDP) in Sweden in 2009 to that in 2010?
Offer a terse response. 0.91. What is the ratio of the Rent(as % of GDP) in Europe(all income levels) in 2009 to that in 2011?
Offer a very short reply. 0.92. What is the ratio of the Rent(as % of GDP) of Guyana in 2009 to that in 2011?
Keep it short and to the point. 0.91. What is the ratio of the Rent(as % of GDP) in Montenegro in 2009 to that in 2011?
Give a very brief answer. 0.42. What is the ratio of the Rent(as % of GDP) of Sweden in 2009 to that in 2011?
Keep it short and to the point. 1.02. What is the ratio of the Rent(as % of GDP) of Europe(all income levels) in 2009 to that in 2012?
Ensure brevity in your answer.  0.86. What is the ratio of the Rent(as % of GDP) of Guyana in 2009 to that in 2012?
Provide a short and direct response. 0.92. What is the ratio of the Rent(as % of GDP) in Montenegro in 2009 to that in 2012?
Offer a very short reply. 0.5. What is the ratio of the Rent(as % of GDP) of Sweden in 2009 to that in 2012?
Provide a succinct answer. 1.17. What is the ratio of the Rent(as % of GDP) in Europe(all income levels) in 2009 to that in 2013?
Offer a very short reply. 0.86. What is the ratio of the Rent(as % of GDP) in Guyana in 2009 to that in 2013?
Provide a succinct answer. 0.94. What is the ratio of the Rent(as % of GDP) in Montenegro in 2009 to that in 2013?
Your answer should be very brief. 0.49. What is the ratio of the Rent(as % of GDP) of Sweden in 2009 to that in 2013?
Your answer should be very brief. 1.19. What is the ratio of the Rent(as % of GDP) of Europe(all income levels) in 2010 to that in 2011?
Make the answer very short. 1.09. What is the ratio of the Rent(as % of GDP) in Guyana in 2010 to that in 2011?
Your response must be concise. 1.37. What is the ratio of the Rent(as % of GDP) in Montenegro in 2010 to that in 2011?
Provide a succinct answer. 0.75. What is the ratio of the Rent(as % of GDP) of Sweden in 2010 to that in 2011?
Ensure brevity in your answer.  1.12. What is the ratio of the Rent(as % of GDP) in Europe(all income levels) in 2010 to that in 2012?
Your response must be concise. 1.02. What is the ratio of the Rent(as % of GDP) of Guyana in 2010 to that in 2012?
Keep it short and to the point. 1.38. What is the ratio of the Rent(as % of GDP) in Montenegro in 2010 to that in 2012?
Your response must be concise. 0.89. What is the ratio of the Rent(as % of GDP) in Sweden in 2010 to that in 2012?
Your response must be concise. 1.28. What is the ratio of the Rent(as % of GDP) of Europe(all income levels) in 2010 to that in 2013?
Make the answer very short. 1.02. What is the ratio of the Rent(as % of GDP) of Guyana in 2010 to that in 2013?
Offer a terse response. 1.41. What is the ratio of the Rent(as % of GDP) of Montenegro in 2010 to that in 2013?
Offer a terse response. 0.88. What is the ratio of the Rent(as % of GDP) of Sweden in 2010 to that in 2013?
Make the answer very short. 1.3. What is the ratio of the Rent(as % of GDP) in Europe(all income levels) in 2011 to that in 2012?
Ensure brevity in your answer.  0.94. What is the ratio of the Rent(as % of GDP) in Guyana in 2011 to that in 2012?
Your answer should be compact. 1.01. What is the ratio of the Rent(as % of GDP) in Montenegro in 2011 to that in 2012?
Your answer should be very brief. 1.19. What is the ratio of the Rent(as % of GDP) in Sweden in 2011 to that in 2012?
Your answer should be very brief. 1.14. What is the ratio of the Rent(as % of GDP) of Europe(all income levels) in 2011 to that in 2013?
Your answer should be compact. 0.94. What is the ratio of the Rent(as % of GDP) in Guyana in 2011 to that in 2013?
Your answer should be very brief. 1.03. What is the ratio of the Rent(as % of GDP) in Montenegro in 2011 to that in 2013?
Provide a succinct answer. 1.18. What is the ratio of the Rent(as % of GDP) in Sweden in 2011 to that in 2013?
Your answer should be compact. 1.16. What is the ratio of the Rent(as % of GDP) of Guyana in 2012 to that in 2013?
Offer a terse response. 1.02. What is the ratio of the Rent(as % of GDP) in Sweden in 2012 to that in 2013?
Your answer should be compact. 1.02. What is the difference between the highest and the second highest Rent(as % of GDP) in Europe(all income levels)?
Offer a terse response. 0. What is the difference between the highest and the second highest Rent(as % of GDP) in Guyana?
Keep it short and to the point. 1.22. What is the difference between the highest and the second highest Rent(as % of GDP) in Montenegro?
Make the answer very short. 0.1. What is the difference between the highest and the second highest Rent(as % of GDP) of Sweden?
Provide a succinct answer. 0.02. What is the difference between the highest and the lowest Rent(as % of GDP) of Europe(all income levels)?
Offer a very short reply. 0.03. What is the difference between the highest and the lowest Rent(as % of GDP) of Guyana?
Your answer should be compact. 2.43. What is the difference between the highest and the lowest Rent(as % of GDP) of Montenegro?
Provide a succinct answer. 0.39. What is the difference between the highest and the lowest Rent(as % of GDP) of Sweden?
Provide a succinct answer. 0.19. 